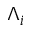<formula> <loc_0><loc_0><loc_500><loc_500>\Lambda _ { i }</formula> 